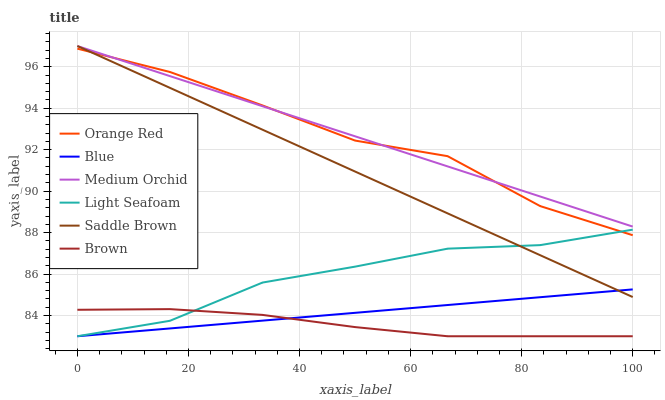Does Brown have the minimum area under the curve?
Answer yes or no. Yes. Does Medium Orchid have the maximum area under the curve?
Answer yes or no. Yes. Does Medium Orchid have the minimum area under the curve?
Answer yes or no. No. Does Brown have the maximum area under the curve?
Answer yes or no. No. Is Saddle Brown the smoothest?
Answer yes or no. Yes. Is Orange Red the roughest?
Answer yes or no. Yes. Is Brown the smoothest?
Answer yes or no. No. Is Brown the roughest?
Answer yes or no. No. Does Blue have the lowest value?
Answer yes or no. Yes. Does Medium Orchid have the lowest value?
Answer yes or no. No. Does Saddle Brown have the highest value?
Answer yes or no. Yes. Does Brown have the highest value?
Answer yes or no. No. Is Light Seafoam less than Medium Orchid?
Answer yes or no. Yes. Is Orange Red greater than Blue?
Answer yes or no. Yes. Does Medium Orchid intersect Orange Red?
Answer yes or no. Yes. Is Medium Orchid less than Orange Red?
Answer yes or no. No. Is Medium Orchid greater than Orange Red?
Answer yes or no. No. Does Light Seafoam intersect Medium Orchid?
Answer yes or no. No. 